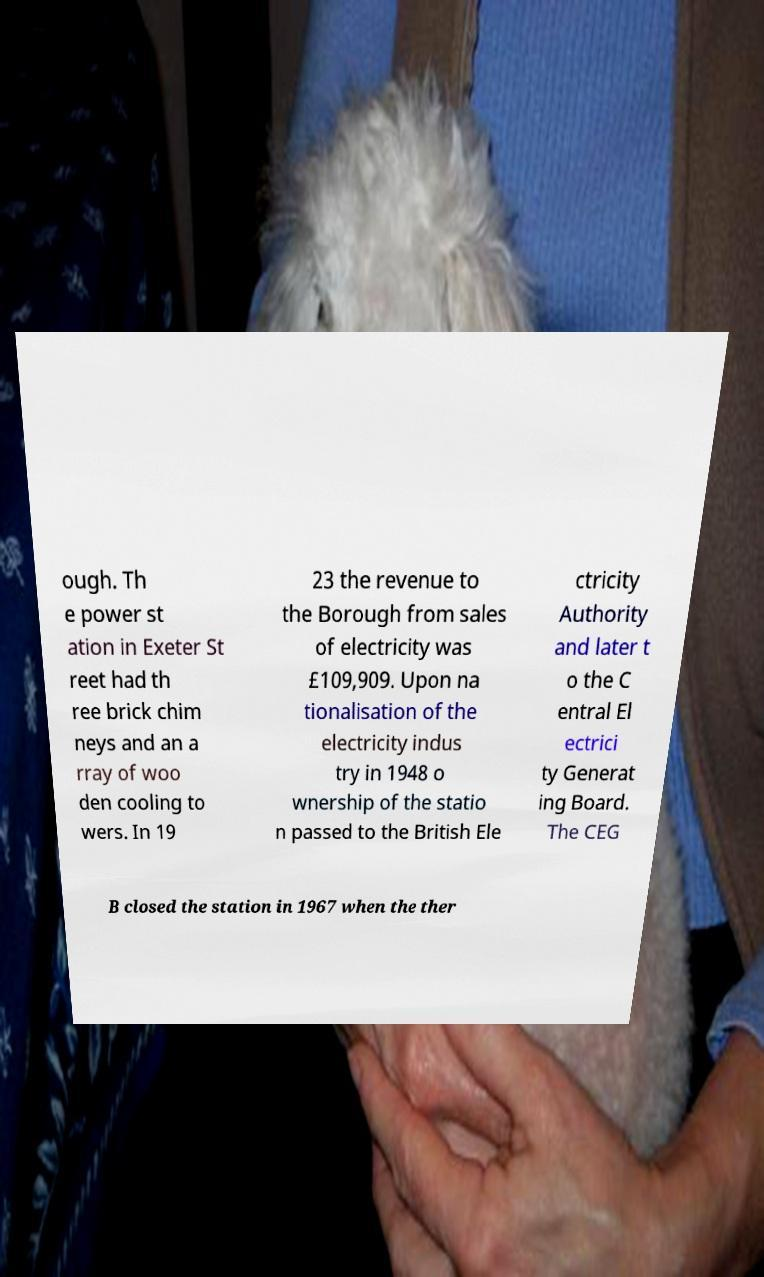Please identify and transcribe the text found in this image. ough. Th e power st ation in Exeter St reet had th ree brick chim neys and an a rray of woo den cooling to wers. In 19 23 the revenue to the Borough from sales of electricity was £109,909. Upon na tionalisation of the electricity indus try in 1948 o wnership of the statio n passed to the British Ele ctricity Authority and later t o the C entral El ectrici ty Generat ing Board. The CEG B closed the station in 1967 when the ther 